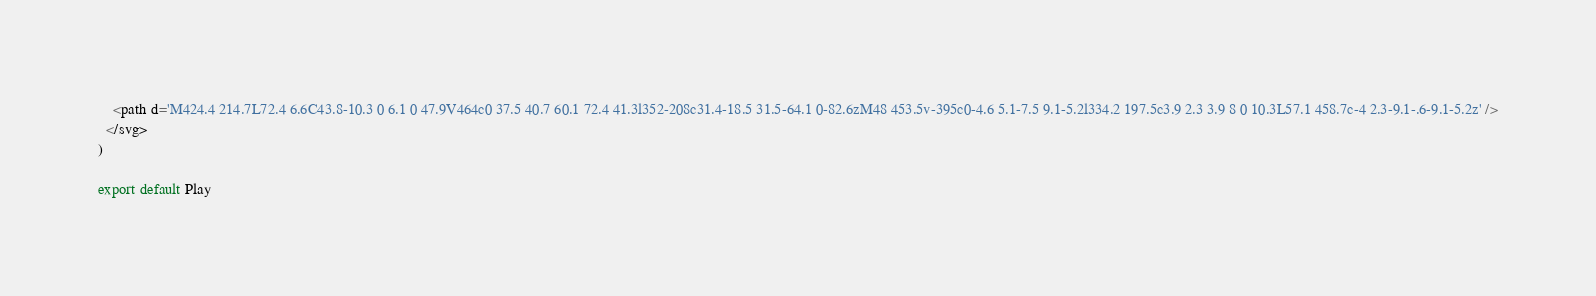Convert code to text. <code><loc_0><loc_0><loc_500><loc_500><_JavaScript_>    <path d='M424.4 214.7L72.4 6.6C43.8-10.3 0 6.1 0 47.9V464c0 37.5 40.7 60.1 72.4 41.3l352-208c31.4-18.5 31.5-64.1 0-82.6zM48 453.5v-395c0-4.6 5.1-7.5 9.1-5.2l334.2 197.5c3.9 2.3 3.9 8 0 10.3L57.1 458.7c-4 2.3-9.1-.6-9.1-5.2z' />
  </svg>
)

export default Play
</code> 